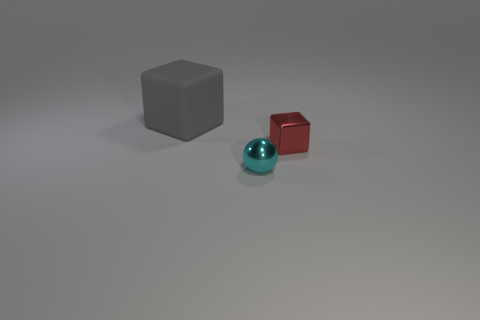Add 3 spheres. How many objects exist? 6 Subtract all spheres. How many objects are left? 2 Subtract 0 brown spheres. How many objects are left? 3 Subtract all gray matte cubes. Subtract all small cyan balls. How many objects are left? 1 Add 3 red blocks. How many red blocks are left? 4 Add 1 red matte objects. How many red matte objects exist? 1 